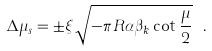<formula> <loc_0><loc_0><loc_500><loc_500>\Delta \mu _ { s } = \pm \xi \sqrt { - \pi R \alpha \beta _ { k } \cot \frac { \mu } { 2 } } \ .</formula> 